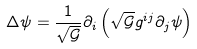Convert formula to latex. <formula><loc_0><loc_0><loc_500><loc_500>\Delta \psi = \frac { 1 } { \sqrt { \mathcal { G } } } \partial _ { i } \left ( \sqrt { \mathcal { G } } g ^ { i j } \partial _ { j } \psi \right )</formula> 